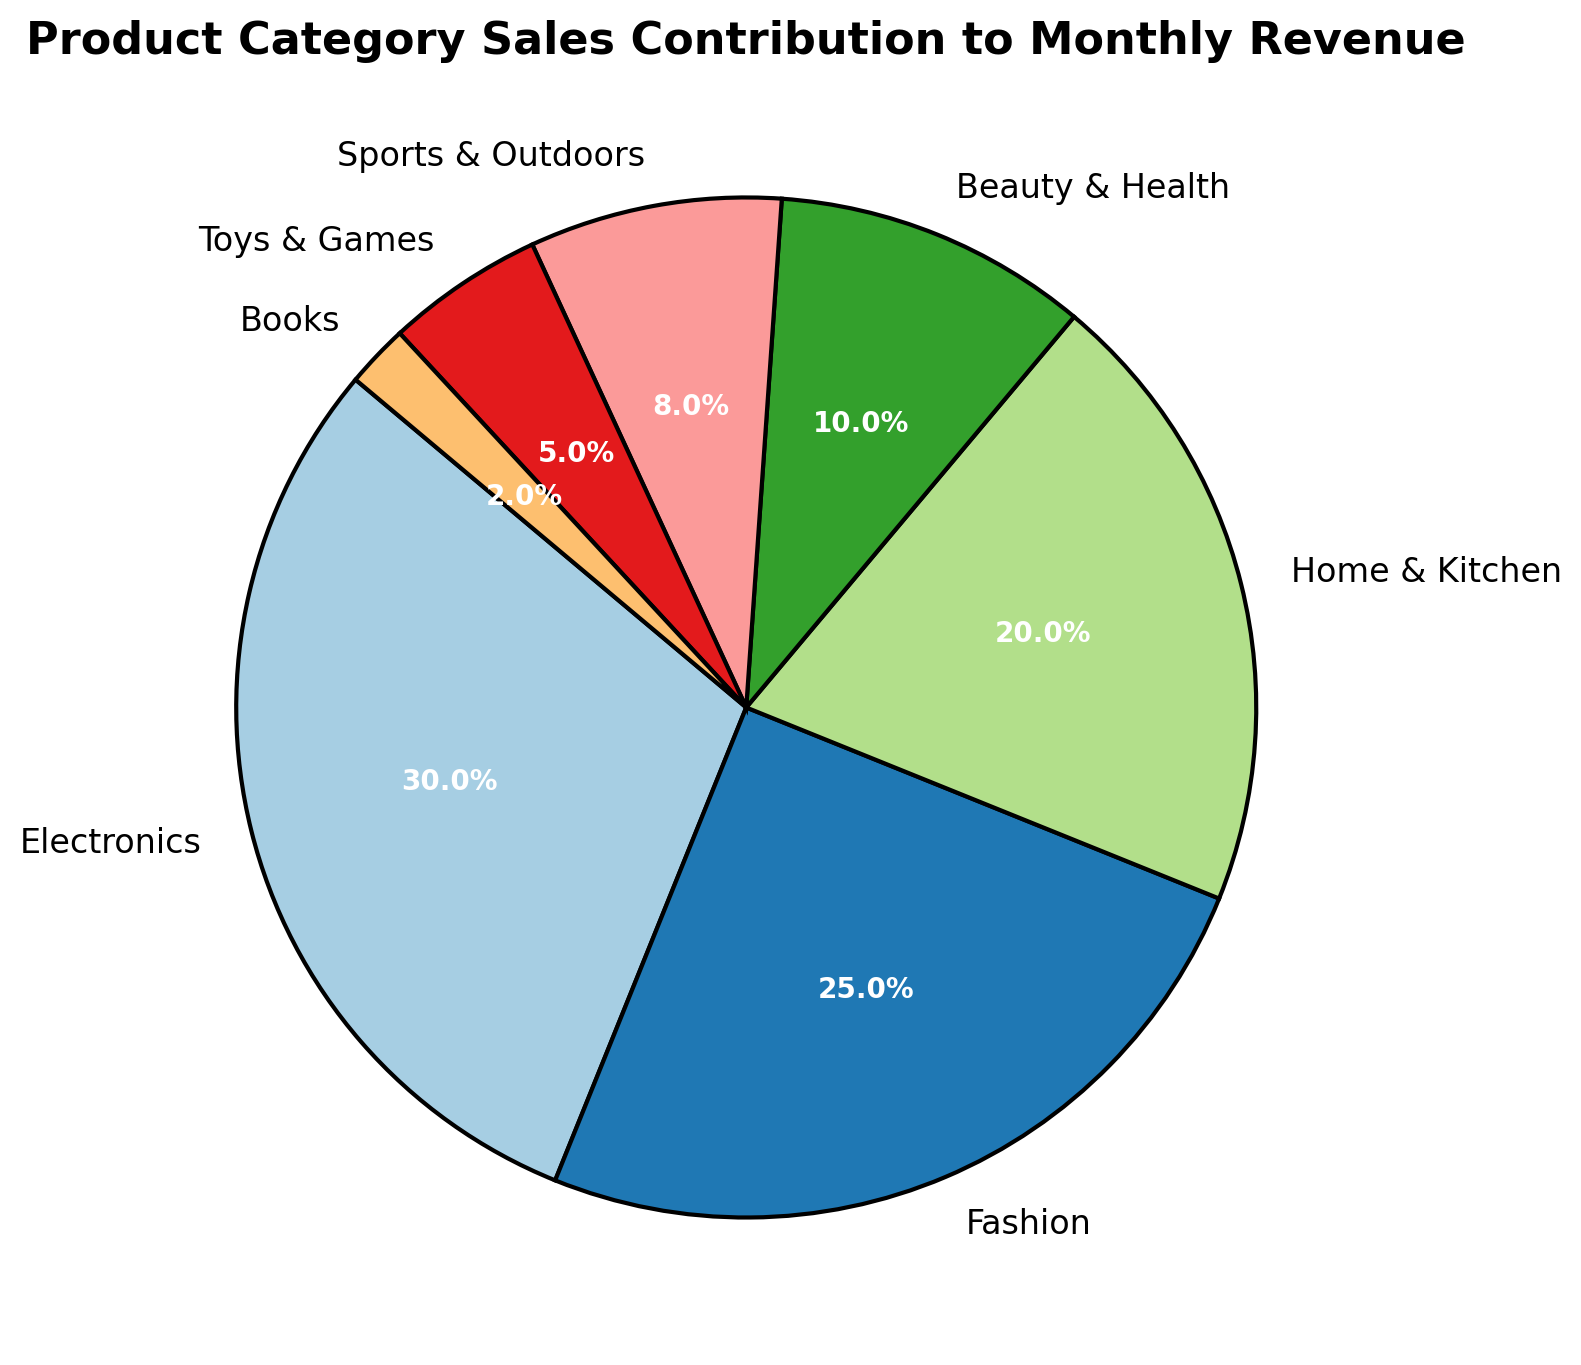Which product category has the highest sales contribution? Look at the pie chart and identify the largest segment. The "Electronics" category has the highest sales contribution at 30%.
Answer: Electronics Which two categories together contribute to more than half of the monthly revenue? Identify the categories with the largest segments and sum their contributions until the total exceeds 50%. "Electronics" (30%) and "Fashion" (25%) together account for 55%.
Answer: Electronics and Fashion How much more does the "Home & Kitchen" category contribute to monthly revenue compared to the "Books" category? Compare the contributions of "Home & Kitchen" (20%) and "Books" (2%) and find the difference: \(20\% - 2\% = 18\%\).
Answer: 18% Is the contribution of the "Sports & Outdoors" category greater or smaller than the "Beauty & Health" category? Compare the percentages of the two categories. "Sports & Outdoors" is 8%, while "Beauty & Health" is 10%. 8% is smaller than 10%.
Answer: Smaller What is the total sales contribution of categories contributing less than 10% each? Add the contributions of "Beauty & Health" (10%), "Sports & Outdoors" (8%), "Toys & Games" (5%), and "Books" (2%): \(10\% + 8\% + 5\% + 2\% = 25\%\).
Answer: 25% Which category's segment is colored in blue? Visually identify the segment colored in blue on the pie chart. The "Fashion" category is usually represented by this color in the "Paired" color scheme.
Answer: Fashion What is the percentage difference between "Fashion" and "Beauty & Health" categories? Subtract the percentage of "Beauty & Health" from "Fashion": \(25\% - 10\% = 15\%\).
Answer: 15% Among the categories, which has the smallest sales contribution and what is its percentage? Find the smallest segment in the pie chart, which corresponds to "Books" with 2%.
Answer: Books, 2% What is the combined sales contribution of the top three categories? Sum the contributions of the top three categories: "Electronics" (30%), "Fashion" (25%), and "Home & Kitchen" (20%): \(30\% + 25\% + 20\% = 75\%\).
Answer: 75% 